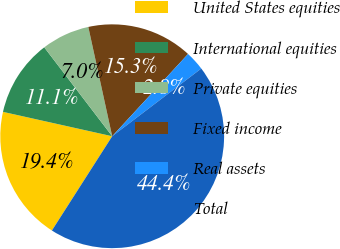<chart> <loc_0><loc_0><loc_500><loc_500><pie_chart><fcel>United States equities<fcel>International equities<fcel>Private equities<fcel>Fixed income<fcel>Real assets<fcel>Total<nl><fcel>19.44%<fcel>11.12%<fcel>6.96%<fcel>15.28%<fcel>2.8%<fcel>44.4%<nl></chart> 